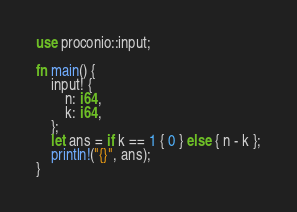Convert code to text. <code><loc_0><loc_0><loc_500><loc_500><_Rust_>use proconio::input;

fn main() {
    input! {
        n: i64,
        k: i64,
    };
    let ans = if k == 1 { 0 } else { n - k };
    println!("{}", ans);
}
</code> 